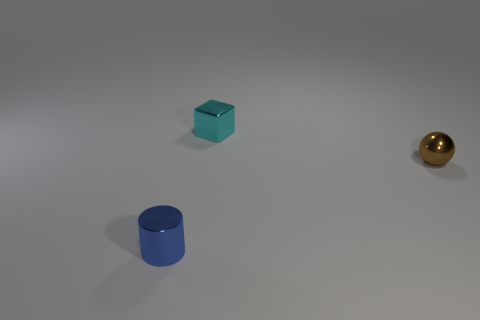Add 2 large purple metallic blocks. How many objects exist? 5 Subtract all cubes. How many objects are left? 2 Add 1 tiny cylinders. How many tiny cylinders exist? 2 Subtract 0 cyan cylinders. How many objects are left? 3 Subtract all blue shiny cylinders. Subtract all yellow metallic cylinders. How many objects are left? 2 Add 3 cyan blocks. How many cyan blocks are left? 4 